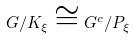Convert formula to latex. <formula><loc_0><loc_0><loc_500><loc_500>G / K _ { \xi } \cong G ^ { c } / P _ { \xi }</formula> 